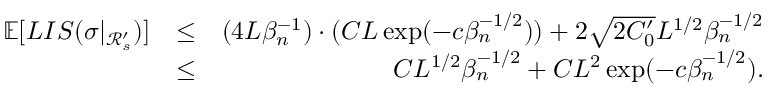Convert formula to latex. <formula><loc_0><loc_0><loc_500><loc_500>\begin{array} { r l r } { \mathbb { E } [ L I S ( \sigma | _ { \mathcal { R } _ { s } ^ { \prime } } ) ] } & { \leq } & { ( 4 L \beta _ { n } ^ { - 1 } ) \cdot ( C L \exp ( - c \beta _ { n } ^ { - 1 \slash 2 } ) ) + 2 \sqrt { 2 C _ { 0 } ^ { \prime } } L ^ { 1 \slash 2 } \beta _ { n } ^ { - 1 \slash 2 } } \\ & { \leq } & { C L ^ { 1 \slash 2 } \beta _ { n } ^ { - 1 \slash 2 } + C L ^ { 2 } \exp ( - c \beta _ { n } ^ { - 1 \slash 2 } ) . } \end{array}</formula> 